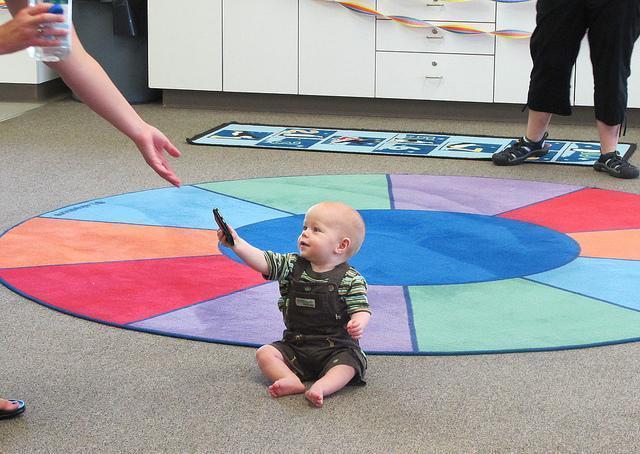How many people are in the picture?
Give a very brief answer. 3. 